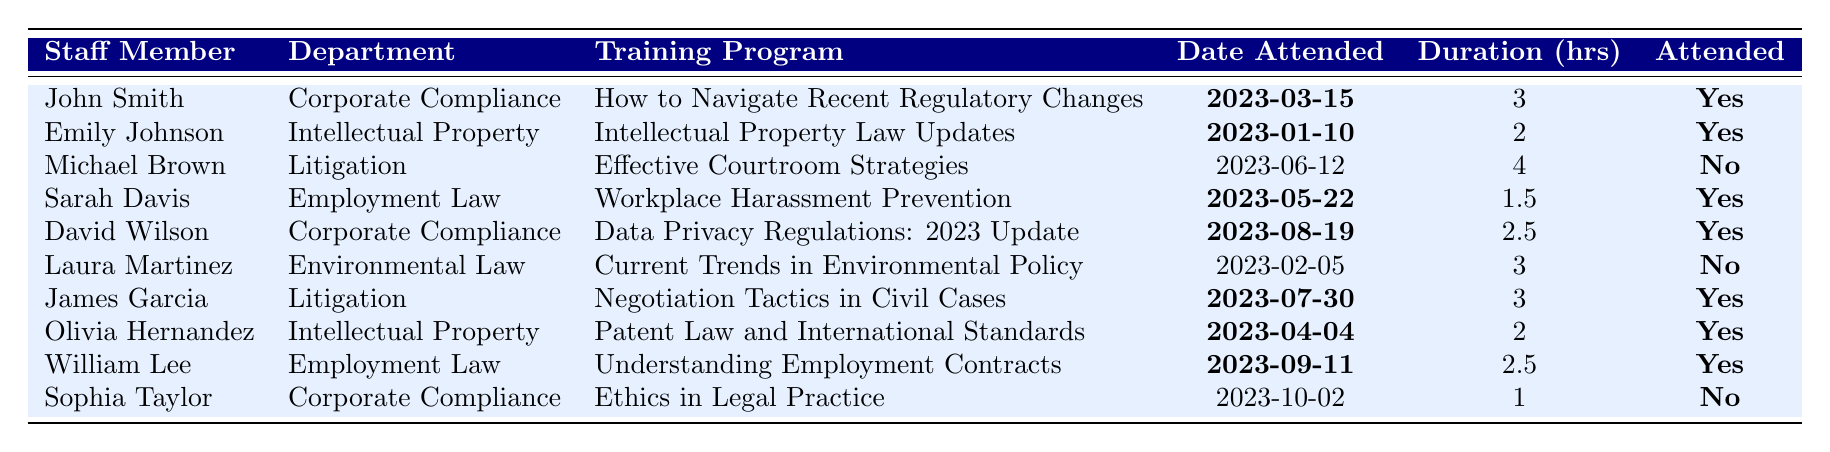What is the training program attended by Sarah Davis? By searching through the table under the "Staff Member" column for Sarah Davis, the corresponding "Training Program" is "Workplace Harassment Prevention."
Answer: Workplace Harassment Prevention How many staff members attended legal training in 2023? By counting the number of "Yes" responses in the "Attended" column, we find that there are 6 staff members who attended training sessions.
Answer: 6 What is the total duration of training hours for all staff who attended? We sum the duration hours for all staff who attended training: 3 (John Smith) + 2 (Emily Johnson) + 1.5 (Sarah Davis) + 2.5 (David Wilson) + 3 (James Garcia) + 2 (Olivia Hernandez) + 2.5 (William Lee) = 14.5 hours.
Answer: 14.5 hours Which department had the most training sessions attended? Counting the number of "Yes" responses for each department: Corporate Compliance (3), Intellectual Property (2), Employment Law (2), Litigation (2), Environmental Law (0). Corporate Compliance has the highest count with 3 sessions attended.
Answer: Corporate Compliance Did Michael Brown attend the training program on Effective Courtroom Strategies? By checking the "Attended" column next to Michael Brown's entry, the value is "No."
Answer: No What is the average duration of training hours for those who attended? We calculate the total hours for attendees (3 + 2 + 1.5 + 2.5 + 3 + 2.5 = 14.5), and divide by the number of attendees (6), resulting in an average of 14.5 / 6 = 2.42 hours.
Answer: 2.42 hours Which staff member attended the training on Data Privacy Regulations? Looking for "Data Privacy Regulations: 2023 Update" in the "Training Program" column, we find that David Wilson is the staff member who attended this training.
Answer: David Wilson How many training programs were attended by staff members from the Corporate Compliance department? By counting the entries for Corporate Compliance with "Yes" in the "Attended" column, we find 3 programs attended.
Answer: 3 What was the date of the training attended by Olivia Hernandez? Searching for Olivia Hernandez in the table, the corresponding "Date Attended" is "2023-04-04."
Answer: 2023-04-04 Did Laura Martinez attend any training sessions in 2023? By checking the "Attended" column next to Laura Martinez’s entry, the value is "No."
Answer: No 